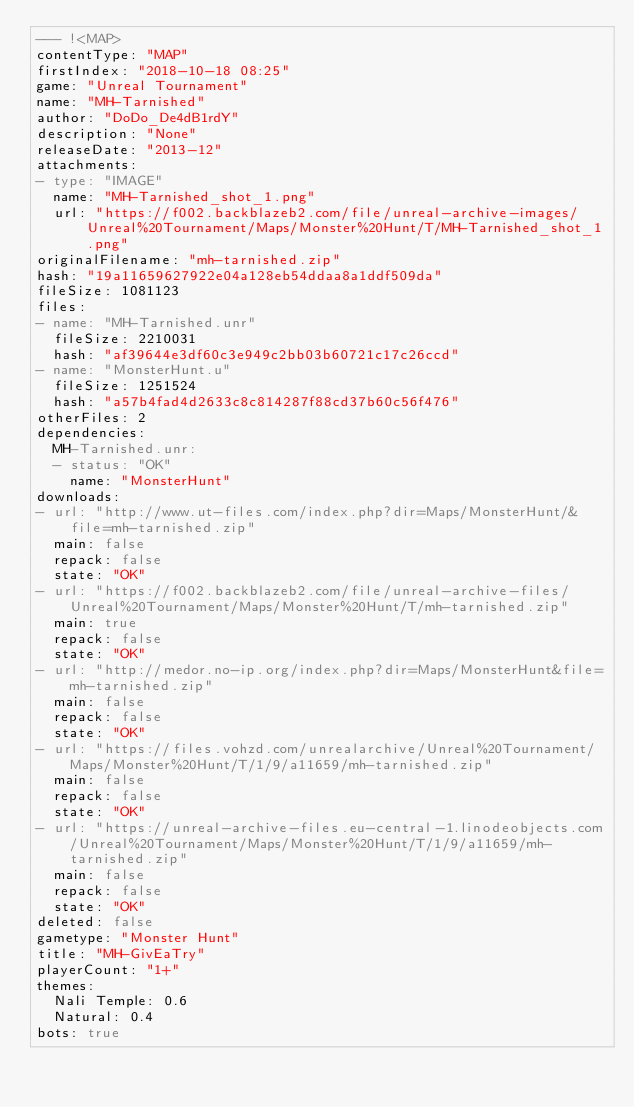<code> <loc_0><loc_0><loc_500><loc_500><_YAML_>--- !<MAP>
contentType: "MAP"
firstIndex: "2018-10-18 08:25"
game: "Unreal Tournament"
name: "MH-Tarnished"
author: "DoDo_De4dB1rdY"
description: "None"
releaseDate: "2013-12"
attachments:
- type: "IMAGE"
  name: "MH-Tarnished_shot_1.png"
  url: "https://f002.backblazeb2.com/file/unreal-archive-images/Unreal%20Tournament/Maps/Monster%20Hunt/T/MH-Tarnished_shot_1.png"
originalFilename: "mh-tarnished.zip"
hash: "19a11659627922e04a128eb54ddaa8a1ddf509da"
fileSize: 1081123
files:
- name: "MH-Tarnished.unr"
  fileSize: 2210031
  hash: "af39644e3df60c3e949c2bb03b60721c17c26ccd"
- name: "MonsterHunt.u"
  fileSize: 1251524
  hash: "a57b4fad4d2633c8c814287f88cd37b60c56f476"
otherFiles: 2
dependencies:
  MH-Tarnished.unr:
  - status: "OK"
    name: "MonsterHunt"
downloads:
- url: "http://www.ut-files.com/index.php?dir=Maps/MonsterHunt/&file=mh-tarnished.zip"
  main: false
  repack: false
  state: "OK"
- url: "https://f002.backblazeb2.com/file/unreal-archive-files/Unreal%20Tournament/Maps/Monster%20Hunt/T/mh-tarnished.zip"
  main: true
  repack: false
  state: "OK"
- url: "http://medor.no-ip.org/index.php?dir=Maps/MonsterHunt&file=mh-tarnished.zip"
  main: false
  repack: false
  state: "OK"
- url: "https://files.vohzd.com/unrealarchive/Unreal%20Tournament/Maps/Monster%20Hunt/T/1/9/a11659/mh-tarnished.zip"
  main: false
  repack: false
  state: "OK"
- url: "https://unreal-archive-files.eu-central-1.linodeobjects.com/Unreal%20Tournament/Maps/Monster%20Hunt/T/1/9/a11659/mh-tarnished.zip"
  main: false
  repack: false
  state: "OK"
deleted: false
gametype: "Monster Hunt"
title: "MH-GivEaTry"
playerCount: "1+"
themes:
  Nali Temple: 0.6
  Natural: 0.4
bots: true
</code> 